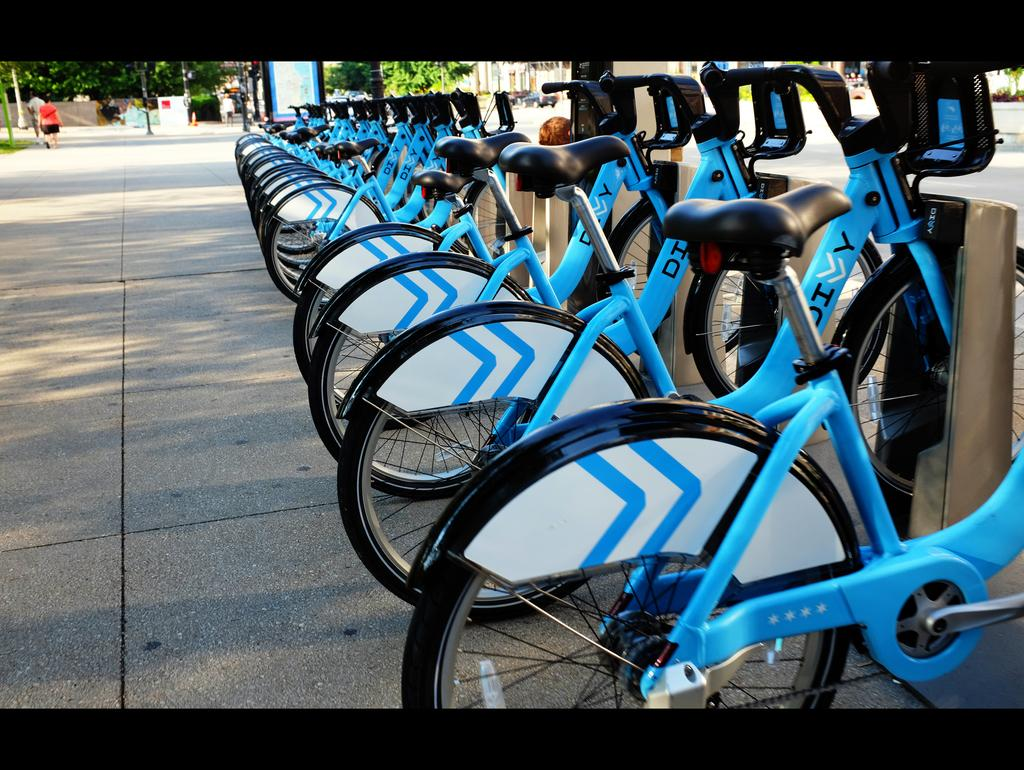What color are the bicycles in the image? The bicycles in the image are blue. What can be seen in the background of the image? There are trees and people standing in the background of the image. What is written on the bicycles? There is writing on the bicycles. What type of meat is being grilled by the people in the image? There is no indication of any meat or grilling in the image; it features blue bicycles with writing on them, surrounded by trees and people in the background. 